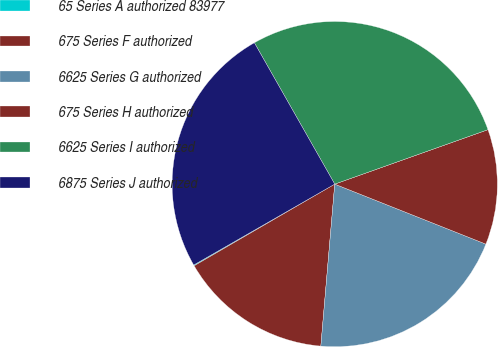Convert chart to OTSL. <chart><loc_0><loc_0><loc_500><loc_500><pie_chart><fcel>65 Series A authorized 83977<fcel>675 Series F authorized<fcel>6625 Series G authorized<fcel>675 Series H authorized<fcel>6625 Series I authorized<fcel>6875 Series J authorized<nl><fcel>0.09%<fcel>15.26%<fcel>20.35%<fcel>11.45%<fcel>27.8%<fcel>25.06%<nl></chart> 